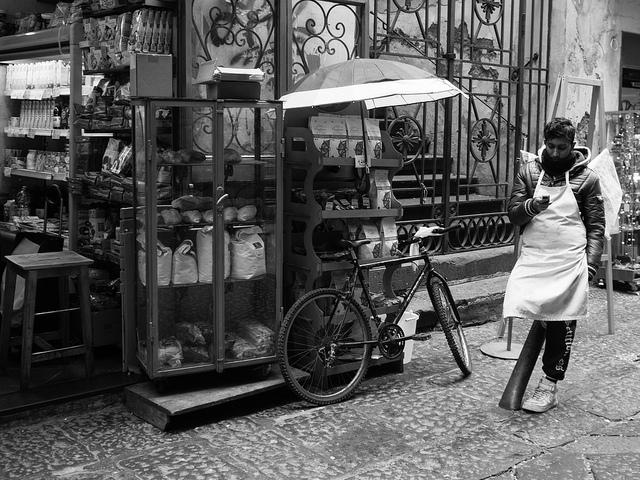Is the man bored?
Be succinct. Yes. What is above the man?
Concise answer only. Umbrella. Which leg is visible?
Give a very brief answer. Left. What hangs all around the shop?
Give a very brief answer. Nothing. What color is his apron?
Quick response, please. White. What is on the man's head?
Concise answer only. Hair. 